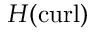Convert formula to latex. <formula><loc_0><loc_0><loc_500><loc_500>H ( c u r l )</formula> 